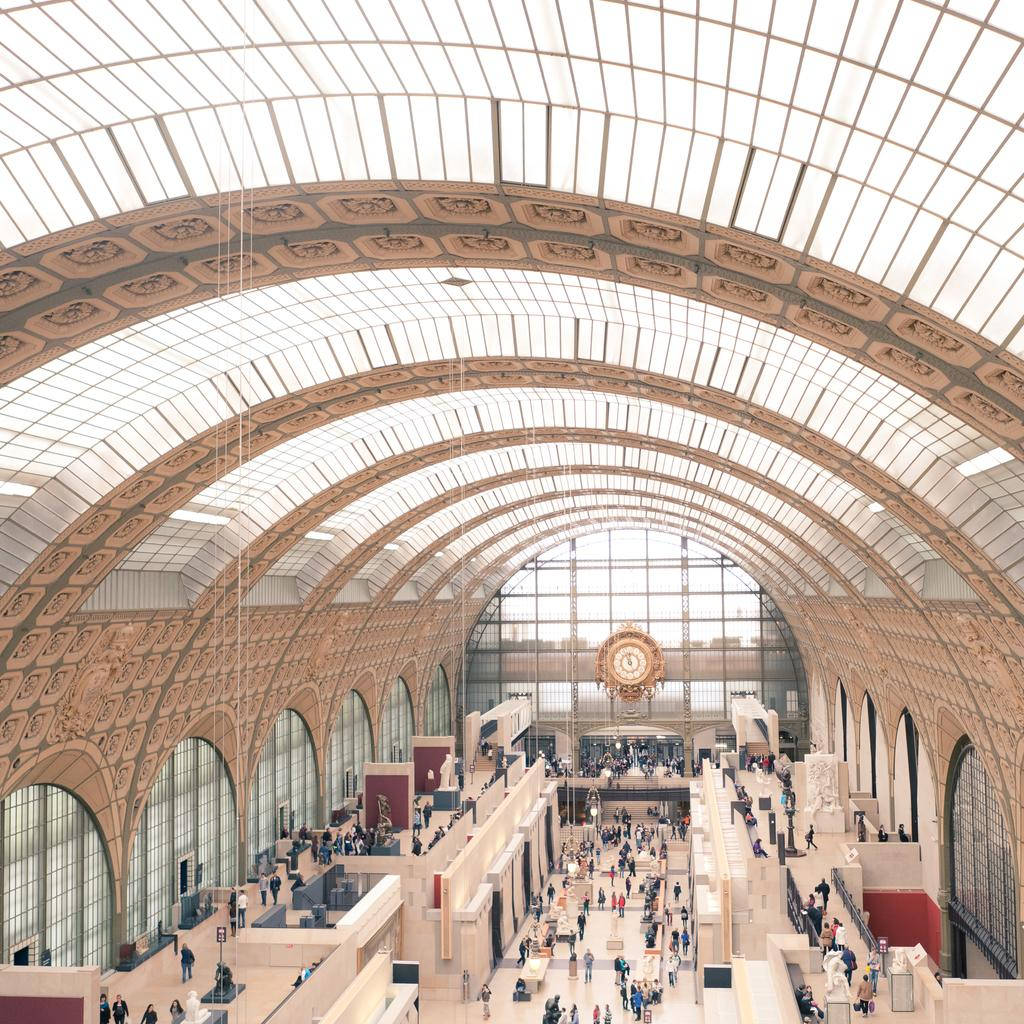Where was the image taken? The image was taken in a hall. What can be seen in the image? There are people in the image. Where are the people located in the image? The people are at the bottom of the image. What architectural features are visible in the image? There are doors visible in the image. What type of industry is depicted in the image? There is no industry depicted in the image; it shows a hall with people and doors. Can you tell me how many people are saying good-bye in the image? There is no indication of anyone saying good-bye in the image; it simply shows people in a hall. 